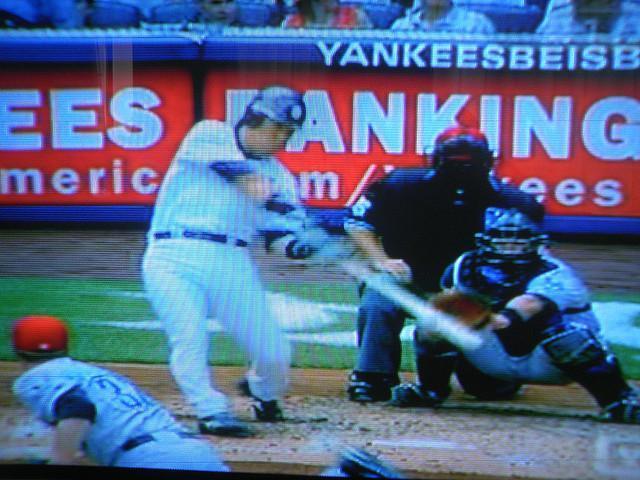How many people can you see?
Give a very brief answer. 6. 